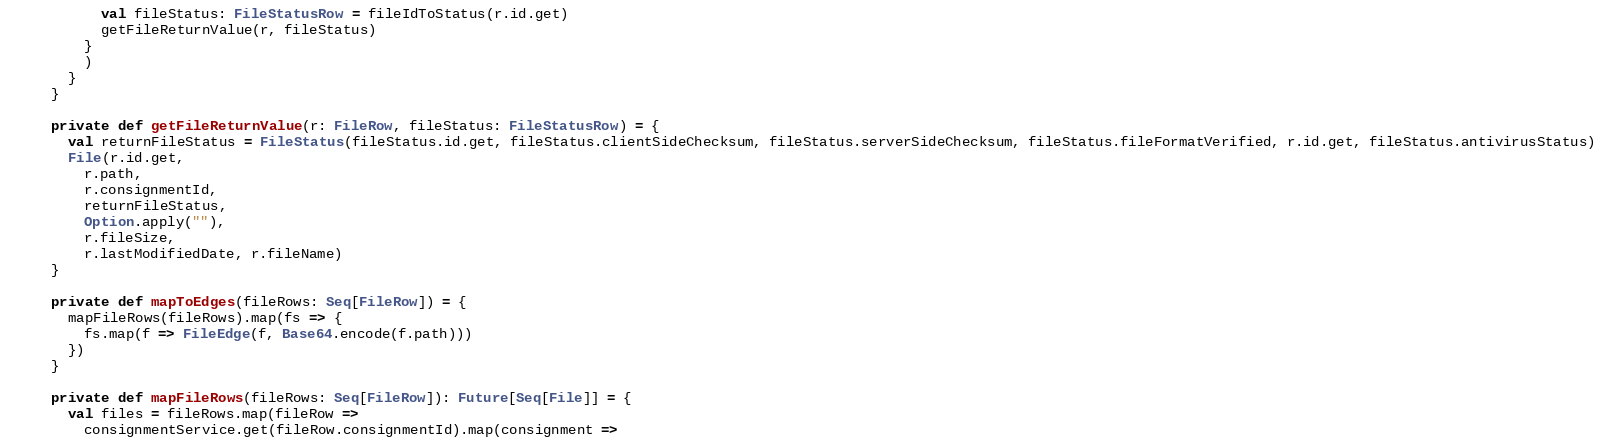<code> <loc_0><loc_0><loc_500><loc_500><_Scala_>        val fileStatus: FileStatusRow = fileIdToStatus(r.id.get)
        getFileReturnValue(r, fileStatus)
      }
      )
    }
  }

  private def getFileReturnValue(r: FileRow, fileStatus: FileStatusRow) = {
    val returnFileStatus = FileStatus(fileStatus.id.get, fileStatus.clientSideChecksum, fileStatus.serverSideChecksum, fileStatus.fileFormatVerified, r.id.get, fileStatus.antivirusStatus)
    File(r.id.get,
      r.path,
      r.consignmentId,
      returnFileStatus,
      Option.apply(""),
      r.fileSize,
      r.lastModifiedDate, r.fileName)
  }

  private def mapToEdges(fileRows: Seq[FileRow]) = {
    mapFileRows(fileRows).map(fs => {
      fs.map(f => FileEdge(f, Base64.encode(f.path)))
    })
  }

  private def mapFileRows(fileRows: Seq[FileRow]): Future[Seq[File]] = {
    val files = fileRows.map(fileRow =>
      consignmentService.get(fileRow.consignmentId).map(consignment =></code> 